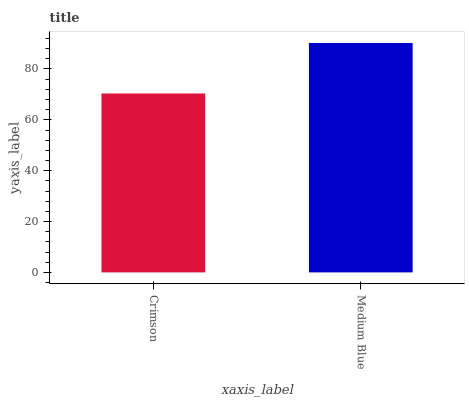Is Crimson the minimum?
Answer yes or no. Yes. Is Medium Blue the maximum?
Answer yes or no. Yes. Is Medium Blue the minimum?
Answer yes or no. No. Is Medium Blue greater than Crimson?
Answer yes or no. Yes. Is Crimson less than Medium Blue?
Answer yes or no. Yes. Is Crimson greater than Medium Blue?
Answer yes or no. No. Is Medium Blue less than Crimson?
Answer yes or no. No. Is Medium Blue the high median?
Answer yes or no. Yes. Is Crimson the low median?
Answer yes or no. Yes. Is Crimson the high median?
Answer yes or no. No. Is Medium Blue the low median?
Answer yes or no. No. 